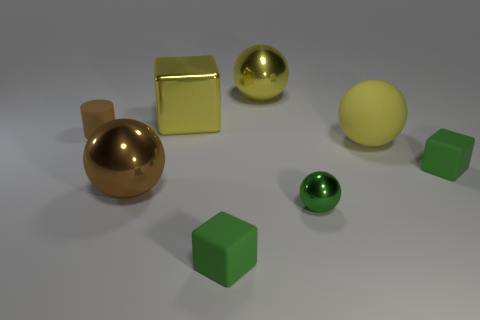What is the material of the big yellow object that is right of the big yellow metallic block and behind the cylinder?
Make the answer very short. Metal. The rubber ball is what color?
Keep it short and to the point. Yellow. How many other objects are the same shape as the small green shiny thing?
Offer a very short reply. 3. Is the brown thing that is behind the big rubber sphere made of the same material as the yellow ball in front of the small brown cylinder?
Make the answer very short. Yes. There is a metallic object that is in front of the large brown metallic thing in front of the brown rubber object; what size is it?
Your answer should be compact. Small. Are there any other things that have the same size as the brown matte thing?
Your response must be concise. Yes. There is another brown thing that is the same shape as the tiny metal object; what material is it?
Your answer should be very brief. Metal. Is the shape of the small thing to the left of the big brown metal sphere the same as the big metal thing that is right of the big cube?
Your answer should be compact. No. Are there more large brown spheres than matte cubes?
Offer a very short reply. No. The brown rubber cylinder has what size?
Provide a succinct answer. Small. 